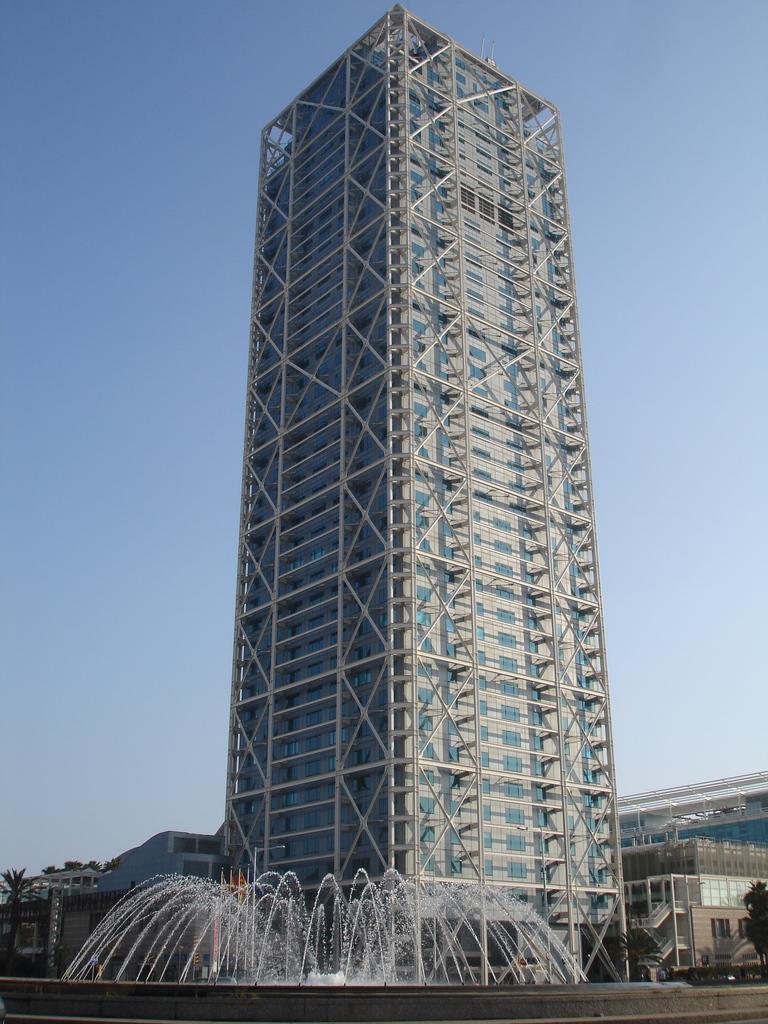Could you give a brief overview of what you see in this image? This picture is clicked outside. In the foreground we can see the fountains. In the center we can see a building and the metal rods. In the background we can see the sky, trees, buildings and some other objects. 